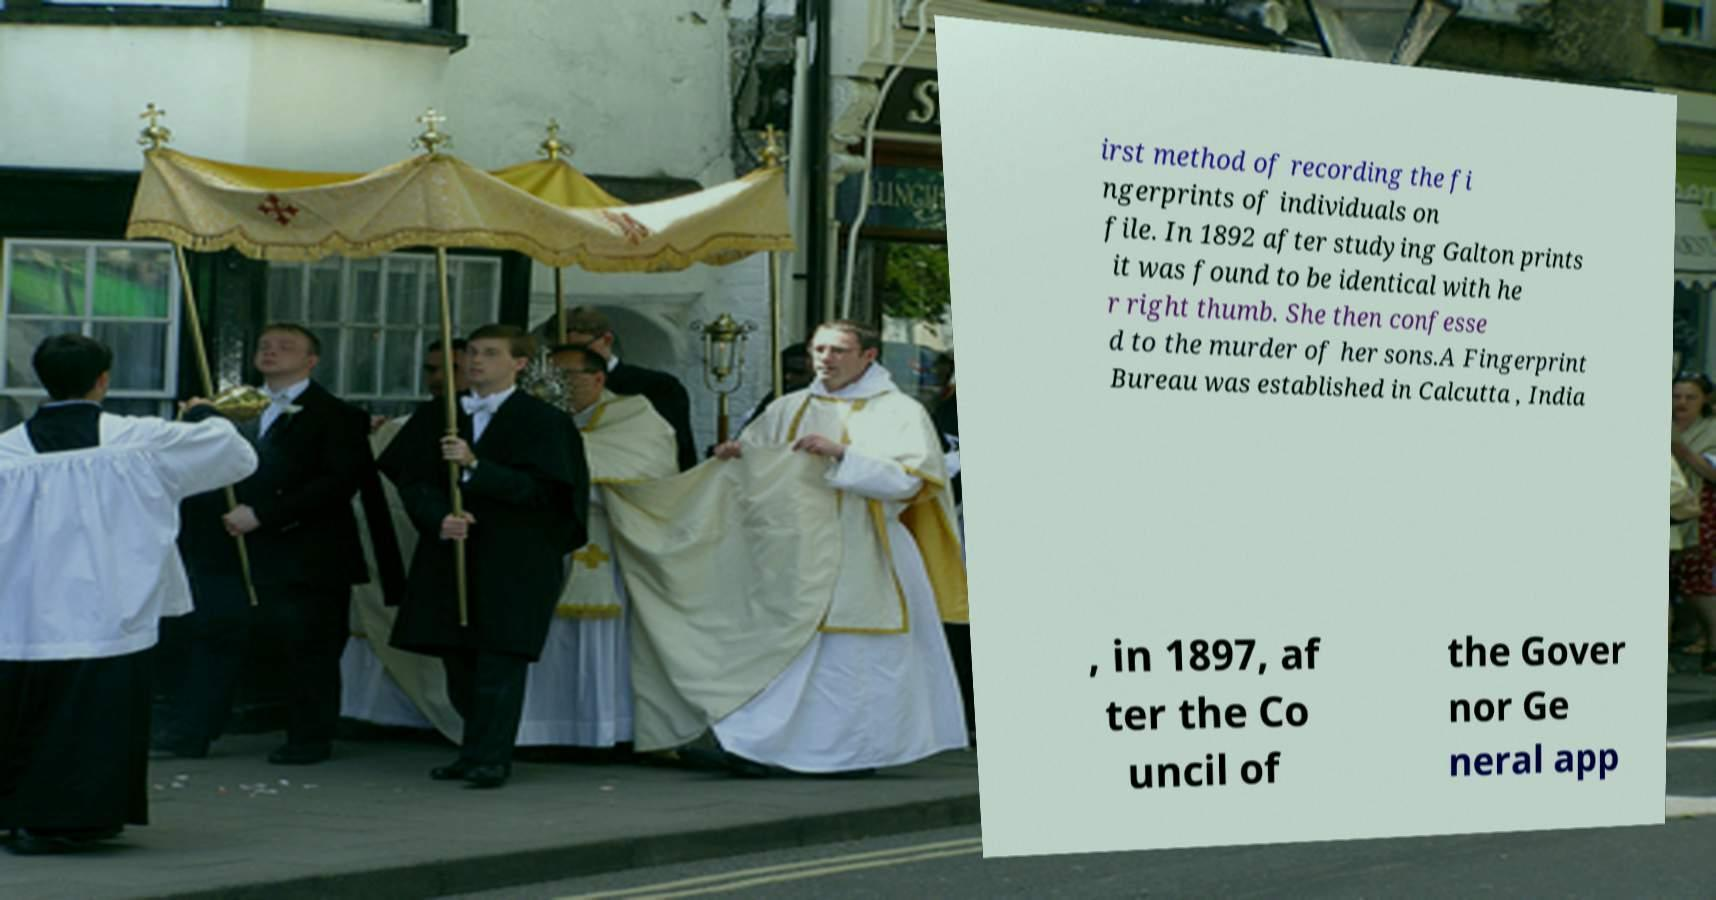Can you accurately transcribe the text from the provided image for me? irst method of recording the fi ngerprints of individuals on file. In 1892 after studying Galton prints it was found to be identical with he r right thumb. She then confesse d to the murder of her sons.A Fingerprint Bureau was established in Calcutta , India , in 1897, af ter the Co uncil of the Gover nor Ge neral app 